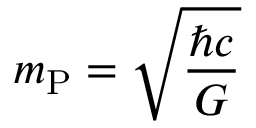Convert formula to latex. <formula><loc_0><loc_0><loc_500><loc_500>m _ { P } = { \sqrt { \frac { \hbar { c } } { G } } }</formula> 